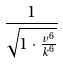Convert formula to latex. <formula><loc_0><loc_0><loc_500><loc_500>\frac { 1 } { \sqrt { 1 \cdot \frac { v ^ { 6 } } { k ^ { 6 } } } }</formula> 